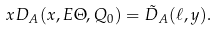Convert formula to latex. <formula><loc_0><loc_0><loc_500><loc_500>x D _ { A } ( x , E \Theta , Q _ { 0 } ) = \tilde { D } _ { A } ( \ell , y ) .</formula> 